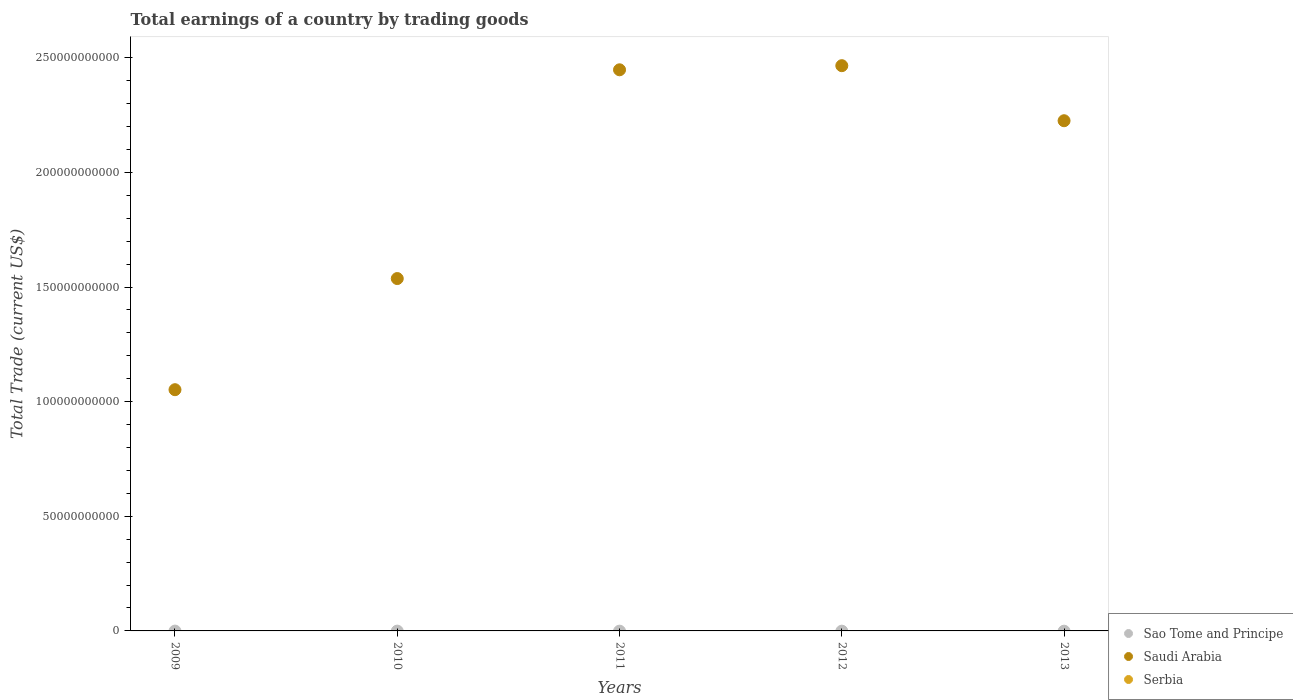Is the number of dotlines equal to the number of legend labels?
Provide a succinct answer. No. What is the total earnings in Sao Tome and Principe in 2009?
Your response must be concise. 0. Across all years, what is the maximum total earnings in Saudi Arabia?
Offer a terse response. 2.47e+11. In which year was the total earnings in Saudi Arabia maximum?
Offer a very short reply. 2012. What is the difference between the total earnings in Saudi Arabia in 2010 and that in 2013?
Give a very brief answer. -6.88e+1. What is the difference between the total earnings in Saudi Arabia in 2011 and the total earnings in Sao Tome and Principe in 2009?
Your answer should be very brief. 2.45e+11. What is the average total earnings in Saudi Arabia per year?
Give a very brief answer. 1.95e+11. In how many years, is the total earnings in Sao Tome and Principe greater than 220000000000 US$?
Offer a terse response. 0. What is the ratio of the total earnings in Saudi Arabia in 2011 to that in 2012?
Give a very brief answer. 0.99. What is the difference between the highest and the second highest total earnings in Saudi Arabia?
Your answer should be compact. 1.80e+09. What is the difference between the highest and the lowest total earnings in Saudi Arabia?
Offer a terse response. 1.41e+11. In how many years, is the total earnings in Saudi Arabia greater than the average total earnings in Saudi Arabia taken over all years?
Ensure brevity in your answer.  3. Is it the case that in every year, the sum of the total earnings in Sao Tome and Principe and total earnings in Saudi Arabia  is greater than the total earnings in Serbia?
Provide a succinct answer. Yes. Does the total earnings in Serbia monotonically increase over the years?
Provide a succinct answer. No. Is the total earnings in Serbia strictly greater than the total earnings in Sao Tome and Principe over the years?
Make the answer very short. No. Is the total earnings in Serbia strictly less than the total earnings in Sao Tome and Principe over the years?
Offer a terse response. Yes. How many years are there in the graph?
Keep it short and to the point. 5. Are the values on the major ticks of Y-axis written in scientific E-notation?
Your response must be concise. No. Does the graph contain grids?
Offer a very short reply. No. Where does the legend appear in the graph?
Give a very brief answer. Bottom right. How many legend labels are there?
Give a very brief answer. 3. What is the title of the graph?
Provide a succinct answer. Total earnings of a country by trading goods. Does "Congo (Democratic)" appear as one of the legend labels in the graph?
Provide a short and direct response. No. What is the label or title of the X-axis?
Give a very brief answer. Years. What is the label or title of the Y-axis?
Your answer should be very brief. Total Trade (current US$). What is the Total Trade (current US$) in Saudi Arabia in 2009?
Ensure brevity in your answer.  1.05e+11. What is the Total Trade (current US$) in Serbia in 2009?
Your answer should be compact. 0. What is the Total Trade (current US$) in Sao Tome and Principe in 2010?
Make the answer very short. 0. What is the Total Trade (current US$) of Saudi Arabia in 2010?
Offer a very short reply. 1.54e+11. What is the Total Trade (current US$) in Serbia in 2010?
Provide a short and direct response. 0. What is the Total Trade (current US$) in Saudi Arabia in 2011?
Your answer should be compact. 2.45e+11. What is the Total Trade (current US$) in Sao Tome and Principe in 2012?
Make the answer very short. 0. What is the Total Trade (current US$) in Saudi Arabia in 2012?
Provide a short and direct response. 2.47e+11. What is the Total Trade (current US$) of Sao Tome and Principe in 2013?
Offer a terse response. 0. What is the Total Trade (current US$) in Saudi Arabia in 2013?
Ensure brevity in your answer.  2.23e+11. What is the Total Trade (current US$) in Serbia in 2013?
Provide a succinct answer. 0. Across all years, what is the maximum Total Trade (current US$) in Saudi Arabia?
Your answer should be very brief. 2.47e+11. Across all years, what is the minimum Total Trade (current US$) in Saudi Arabia?
Keep it short and to the point. 1.05e+11. What is the total Total Trade (current US$) of Sao Tome and Principe in the graph?
Your answer should be compact. 0. What is the total Total Trade (current US$) in Saudi Arabia in the graph?
Provide a short and direct response. 9.73e+11. What is the total Total Trade (current US$) of Serbia in the graph?
Keep it short and to the point. 0. What is the difference between the Total Trade (current US$) of Saudi Arabia in 2009 and that in 2010?
Give a very brief answer. -4.85e+1. What is the difference between the Total Trade (current US$) in Saudi Arabia in 2009 and that in 2011?
Your answer should be very brief. -1.40e+11. What is the difference between the Total Trade (current US$) of Saudi Arabia in 2009 and that in 2012?
Provide a succinct answer. -1.41e+11. What is the difference between the Total Trade (current US$) of Saudi Arabia in 2009 and that in 2013?
Provide a short and direct response. -1.17e+11. What is the difference between the Total Trade (current US$) of Saudi Arabia in 2010 and that in 2011?
Make the answer very short. -9.11e+1. What is the difference between the Total Trade (current US$) in Saudi Arabia in 2010 and that in 2012?
Your answer should be very brief. -9.29e+1. What is the difference between the Total Trade (current US$) of Saudi Arabia in 2010 and that in 2013?
Your answer should be compact. -6.88e+1. What is the difference between the Total Trade (current US$) of Saudi Arabia in 2011 and that in 2012?
Provide a short and direct response. -1.80e+09. What is the difference between the Total Trade (current US$) in Saudi Arabia in 2011 and that in 2013?
Make the answer very short. 2.22e+1. What is the difference between the Total Trade (current US$) of Saudi Arabia in 2012 and that in 2013?
Your answer should be very brief. 2.40e+1. What is the average Total Trade (current US$) of Sao Tome and Principe per year?
Your response must be concise. 0. What is the average Total Trade (current US$) of Saudi Arabia per year?
Your answer should be very brief. 1.95e+11. What is the average Total Trade (current US$) of Serbia per year?
Offer a terse response. 0. What is the ratio of the Total Trade (current US$) of Saudi Arabia in 2009 to that in 2010?
Your answer should be compact. 0.68. What is the ratio of the Total Trade (current US$) of Saudi Arabia in 2009 to that in 2011?
Offer a terse response. 0.43. What is the ratio of the Total Trade (current US$) of Saudi Arabia in 2009 to that in 2012?
Your response must be concise. 0.43. What is the ratio of the Total Trade (current US$) in Saudi Arabia in 2009 to that in 2013?
Provide a short and direct response. 0.47. What is the ratio of the Total Trade (current US$) in Saudi Arabia in 2010 to that in 2011?
Your answer should be compact. 0.63. What is the ratio of the Total Trade (current US$) of Saudi Arabia in 2010 to that in 2012?
Your answer should be compact. 0.62. What is the ratio of the Total Trade (current US$) in Saudi Arabia in 2010 to that in 2013?
Your answer should be very brief. 0.69. What is the ratio of the Total Trade (current US$) in Saudi Arabia in 2011 to that in 2012?
Provide a succinct answer. 0.99. What is the ratio of the Total Trade (current US$) of Saudi Arabia in 2011 to that in 2013?
Offer a terse response. 1.1. What is the ratio of the Total Trade (current US$) in Saudi Arabia in 2012 to that in 2013?
Your response must be concise. 1.11. What is the difference between the highest and the second highest Total Trade (current US$) of Saudi Arabia?
Your answer should be compact. 1.80e+09. What is the difference between the highest and the lowest Total Trade (current US$) of Saudi Arabia?
Provide a short and direct response. 1.41e+11. 